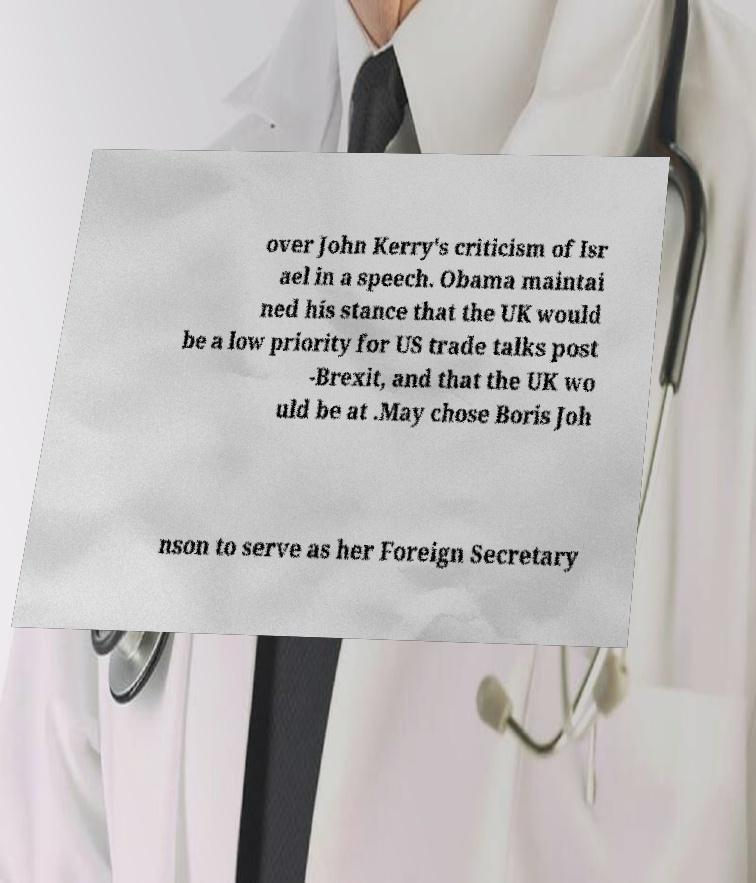I need the written content from this picture converted into text. Can you do that? over John Kerry's criticism of Isr ael in a speech. Obama maintai ned his stance that the UK would be a low priority for US trade talks post -Brexit, and that the UK wo uld be at .May chose Boris Joh nson to serve as her Foreign Secretary 